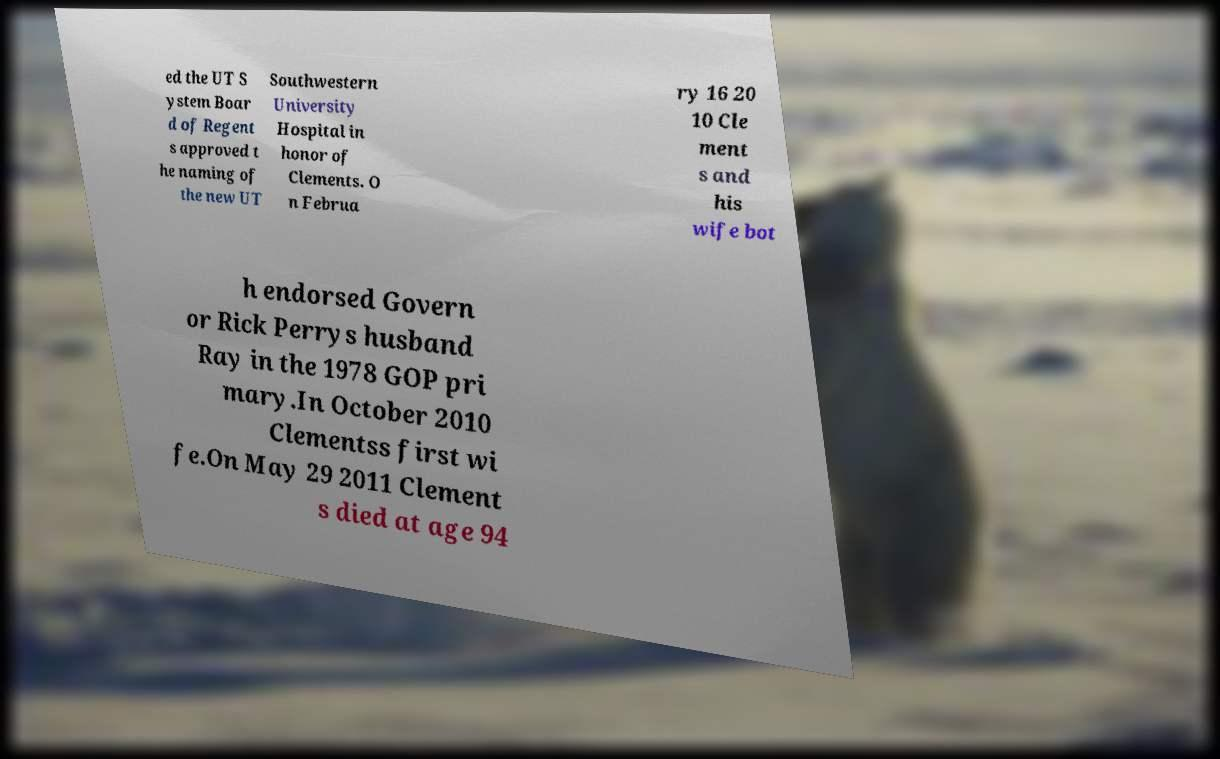I need the written content from this picture converted into text. Can you do that? ed the UT S ystem Boar d of Regent s approved t he naming of the new UT Southwestern University Hospital in honor of Clements. O n Februa ry 16 20 10 Cle ment s and his wife bot h endorsed Govern or Rick Perrys husband Ray in the 1978 GOP pri mary.In October 2010 Clementss first wi fe.On May 29 2011 Clement s died at age 94 